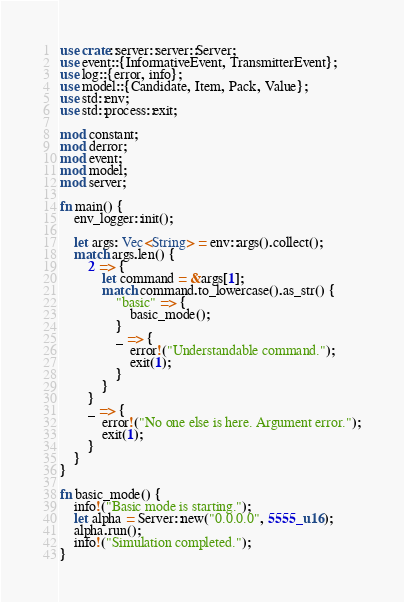Convert code to text. <code><loc_0><loc_0><loc_500><loc_500><_Rust_>use crate::server::server::Server;
use event::{InformativeEvent, TransmitterEvent};
use log::{error, info};
use model::{Candidate, Item, Pack, Value};
use std::env;
use std::process::exit;

mod constant;
mod derror;
mod event;
mod model;
mod server;

fn main() {
    env_logger::init();

    let args: Vec<String> = env::args().collect();
    match args.len() {
        2 => {
            let command = &args[1];
            match command.to_lowercase().as_str() {
                "basic" => {
                    basic_mode();
                }
                _ => {
                    error!("Understandable command.");
                    exit(1);
                }
            }
        }
        _ => {
            error!("No one else is here. Argument error.");
            exit(1);
        }
    }
}

fn basic_mode() {
    info!("Basic mode is starting.");
    let alpha = Server::new("0.0.0.0", 5555_u16);
    alpha.run();
    info!("Simulation completed.");
}
</code> 